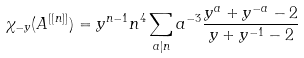Convert formula to latex. <formula><loc_0><loc_0><loc_500><loc_500>\chi _ { - y } ( A ^ { [ [ n ] ] } ) = y ^ { n - 1 } n ^ { 4 } \sum _ { a | n } a ^ { - 3 } \frac { y ^ { a } + y ^ { - a } - 2 } { y + y ^ { - 1 } - 2 }</formula> 